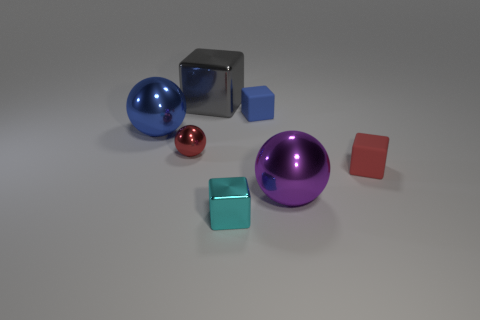How many objects are behind the tiny red ball and left of the blue rubber object?
Ensure brevity in your answer.  2. There is a matte cube in front of the small rubber thing that is behind the tiny red matte thing; how big is it?
Provide a succinct answer. Small. Is the number of blue metal objects greater than the number of blocks?
Ensure brevity in your answer.  No. Is the color of the small matte block in front of the large blue sphere the same as the tiny metallic object behind the cyan thing?
Your response must be concise. Yes. Are there any tiny matte cubes to the left of the rubber block that is to the right of the small blue matte object?
Offer a terse response. Yes. Is the number of large blue metal balls in front of the tiny cyan metal thing less than the number of cyan metal cubes behind the blue shiny ball?
Give a very brief answer. No. Do the red thing to the left of the gray thing and the small block that is behind the blue sphere have the same material?
Offer a very short reply. No. What number of tiny objects are purple spheres or matte spheres?
Provide a succinct answer. 0. There is a big blue thing that is the same material as the red sphere; what is its shape?
Keep it short and to the point. Sphere. Are there fewer cyan metal objects that are to the left of the cyan metal block than tiny purple metal cubes?
Make the answer very short. No. 